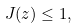Convert formula to latex. <formula><loc_0><loc_0><loc_500><loc_500>J ( z ) \leq 1 ,</formula> 